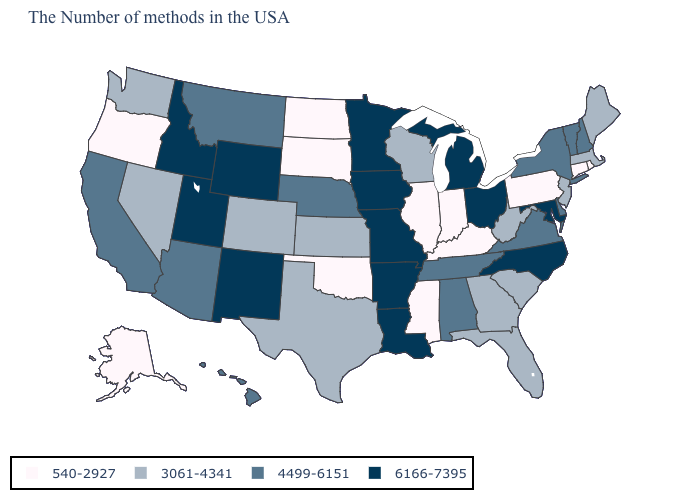Name the states that have a value in the range 540-2927?
Keep it brief. Rhode Island, Connecticut, Pennsylvania, Kentucky, Indiana, Illinois, Mississippi, Oklahoma, South Dakota, North Dakota, Oregon, Alaska. Does New Mexico have the highest value in the USA?
Write a very short answer. Yes. What is the value of Wyoming?
Short answer required. 6166-7395. What is the value of Virginia?
Concise answer only. 4499-6151. Among the states that border Massachusetts , does Rhode Island have the highest value?
Answer briefly. No. Name the states that have a value in the range 540-2927?
Be succinct. Rhode Island, Connecticut, Pennsylvania, Kentucky, Indiana, Illinois, Mississippi, Oklahoma, South Dakota, North Dakota, Oregon, Alaska. Does Georgia have the same value as Arkansas?
Quick response, please. No. Is the legend a continuous bar?
Quick response, please. No. Does Rhode Island have the lowest value in the USA?
Answer briefly. Yes. Name the states that have a value in the range 4499-6151?
Keep it brief. New Hampshire, Vermont, New York, Delaware, Virginia, Alabama, Tennessee, Nebraska, Montana, Arizona, California, Hawaii. What is the value of Nevada?
Keep it brief. 3061-4341. What is the value of Maryland?
Write a very short answer. 6166-7395. Does Michigan have the highest value in the MidWest?
Give a very brief answer. Yes. Does Wyoming have the lowest value in the West?
Short answer required. No. Among the states that border Vermont , which have the lowest value?
Give a very brief answer. Massachusetts. 